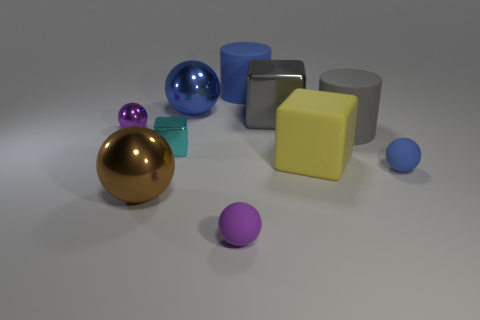Subtract all big spheres. How many spheres are left? 3 Subtract all blue cylinders. How many cylinders are left? 1 Subtract all cylinders. How many objects are left? 8 Subtract 1 cylinders. How many cylinders are left? 1 Subtract all cyan spheres. Subtract all red blocks. How many spheres are left? 5 Subtract all purple cubes. How many gray cylinders are left? 1 Subtract all small red balls. Subtract all blue cylinders. How many objects are left? 9 Add 5 blue objects. How many blue objects are left? 8 Add 2 large gray cylinders. How many large gray cylinders exist? 3 Subtract 0 purple blocks. How many objects are left? 10 